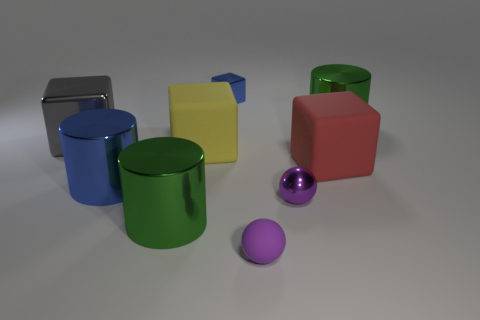How many things are either tiny blue spheres or tiny purple shiny spheres?
Your answer should be compact. 1. There is a block right of the purple shiny thing; is its size the same as the gray cube?
Provide a succinct answer. Yes. What size is the rubber thing that is both behind the large blue cylinder and in front of the yellow rubber object?
Your answer should be very brief. Large. How many other things are the same shape as the gray thing?
Ensure brevity in your answer.  3. How many other things are there of the same material as the big yellow object?
Provide a succinct answer. 2. The other matte thing that is the same shape as the big red object is what size?
Offer a terse response. Large. Does the small block have the same color as the small rubber sphere?
Your answer should be compact. No. There is a metal object that is both to the left of the tiny rubber thing and behind the big gray metal cube; what color is it?
Give a very brief answer. Blue. What number of things are either rubber objects that are on the left side of the blue cube or green things?
Offer a very short reply. 3. What is the color of the other big metal object that is the same shape as the red object?
Your response must be concise. Gray. 